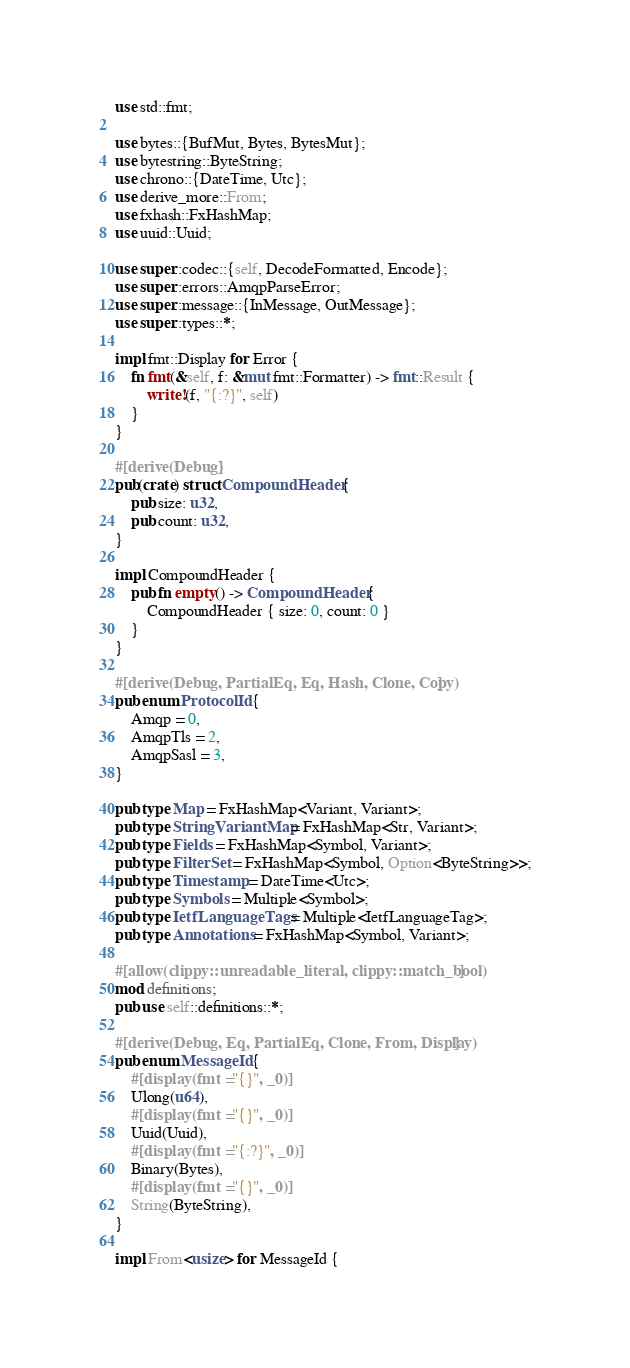<code> <loc_0><loc_0><loc_500><loc_500><_Rust_>use std::fmt;

use bytes::{BufMut, Bytes, BytesMut};
use bytestring::ByteString;
use chrono::{DateTime, Utc};
use derive_more::From;
use fxhash::FxHashMap;
use uuid::Uuid;

use super::codec::{self, DecodeFormatted, Encode};
use super::errors::AmqpParseError;
use super::message::{InMessage, OutMessage};
use super::types::*;

impl fmt::Display for Error {
    fn fmt(&self, f: &mut fmt::Formatter) -> fmt::Result {
        write!(f, "{:?}", self)
    }
}

#[derive(Debug)]
pub(crate) struct CompoundHeader {
    pub size: u32,
    pub count: u32,
}

impl CompoundHeader {
    pub fn empty() -> CompoundHeader {
        CompoundHeader { size: 0, count: 0 }
    }
}

#[derive(Debug, PartialEq, Eq, Hash, Clone, Copy)]
pub enum ProtocolId {
    Amqp = 0,
    AmqpTls = 2,
    AmqpSasl = 3,
}

pub type Map = FxHashMap<Variant, Variant>;
pub type StringVariantMap = FxHashMap<Str, Variant>;
pub type Fields = FxHashMap<Symbol, Variant>;
pub type FilterSet = FxHashMap<Symbol, Option<ByteString>>;
pub type Timestamp = DateTime<Utc>;
pub type Symbols = Multiple<Symbol>;
pub type IetfLanguageTags = Multiple<IetfLanguageTag>;
pub type Annotations = FxHashMap<Symbol, Variant>;

#[allow(clippy::unreadable_literal, clippy::match_bool)]
mod definitions;
pub use self::definitions::*;

#[derive(Debug, Eq, PartialEq, Clone, From, Display)]
pub enum MessageId {
    #[display(fmt = "{}", _0)]
    Ulong(u64),
    #[display(fmt = "{}", _0)]
    Uuid(Uuid),
    #[display(fmt = "{:?}", _0)]
    Binary(Bytes),
    #[display(fmt = "{}", _0)]
    String(ByteString),
}

impl From<usize> for MessageId {</code> 